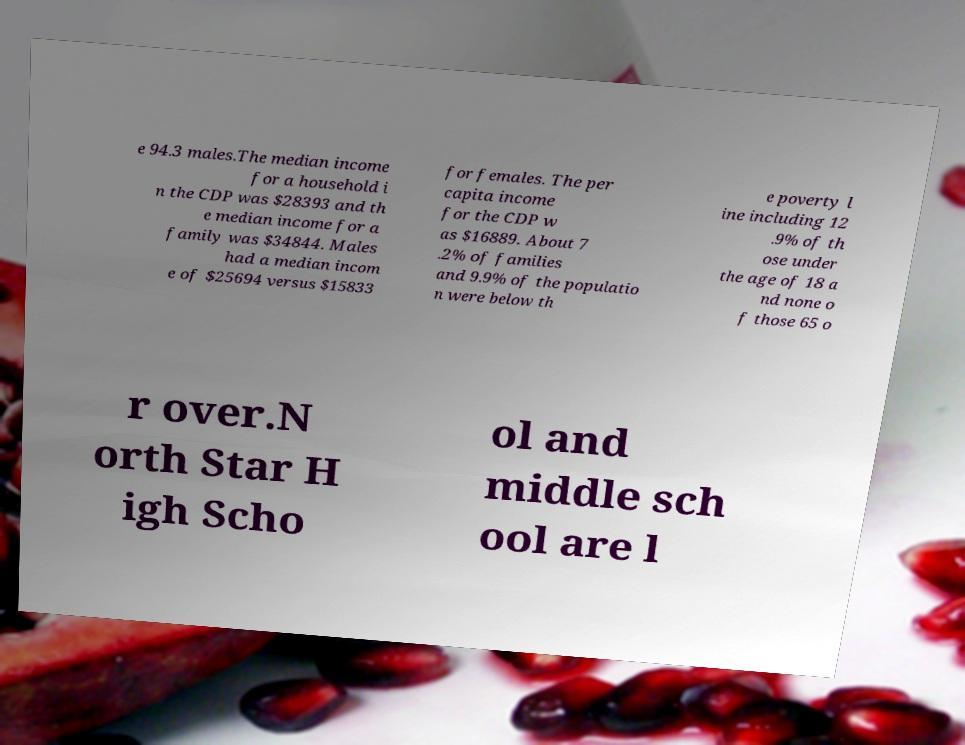I need the written content from this picture converted into text. Can you do that? e 94.3 males.The median income for a household i n the CDP was $28393 and th e median income for a family was $34844. Males had a median incom e of $25694 versus $15833 for females. The per capita income for the CDP w as $16889. About 7 .2% of families and 9.9% of the populatio n were below th e poverty l ine including 12 .9% of th ose under the age of 18 a nd none o f those 65 o r over.N orth Star H igh Scho ol and middle sch ool are l 